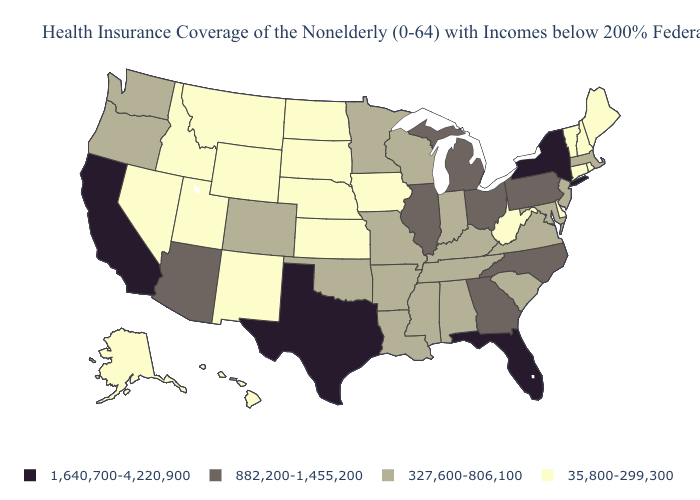Does Wisconsin have a lower value than Arizona?
Be succinct. Yes. Name the states that have a value in the range 882,200-1,455,200?
Be succinct. Arizona, Georgia, Illinois, Michigan, North Carolina, Ohio, Pennsylvania. What is the value of Hawaii?
Give a very brief answer. 35,800-299,300. What is the value of Pennsylvania?
Answer briefly. 882,200-1,455,200. What is the highest value in the South ?
Short answer required. 1,640,700-4,220,900. What is the value of Massachusetts?
Write a very short answer. 327,600-806,100. What is the value of Kentucky?
Give a very brief answer. 327,600-806,100. What is the highest value in the West ?
Be succinct. 1,640,700-4,220,900. Name the states that have a value in the range 35,800-299,300?
Answer briefly. Alaska, Connecticut, Delaware, Hawaii, Idaho, Iowa, Kansas, Maine, Montana, Nebraska, Nevada, New Hampshire, New Mexico, North Dakota, Rhode Island, South Dakota, Utah, Vermont, West Virginia, Wyoming. Name the states that have a value in the range 327,600-806,100?
Keep it brief. Alabama, Arkansas, Colorado, Indiana, Kentucky, Louisiana, Maryland, Massachusetts, Minnesota, Mississippi, Missouri, New Jersey, Oklahoma, Oregon, South Carolina, Tennessee, Virginia, Washington, Wisconsin. Name the states that have a value in the range 882,200-1,455,200?
Be succinct. Arizona, Georgia, Illinois, Michigan, North Carolina, Ohio, Pennsylvania. What is the value of Massachusetts?
Short answer required. 327,600-806,100. Is the legend a continuous bar?
Quick response, please. No. Does California have the highest value in the USA?
Answer briefly. Yes. 